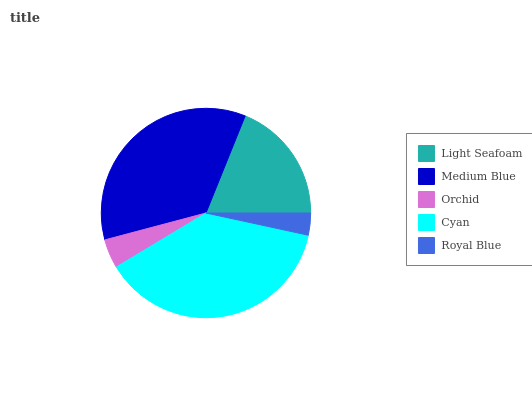Is Royal Blue the minimum?
Answer yes or no. Yes. Is Cyan the maximum?
Answer yes or no. Yes. Is Medium Blue the minimum?
Answer yes or no. No. Is Medium Blue the maximum?
Answer yes or no. No. Is Medium Blue greater than Light Seafoam?
Answer yes or no. Yes. Is Light Seafoam less than Medium Blue?
Answer yes or no. Yes. Is Light Seafoam greater than Medium Blue?
Answer yes or no. No. Is Medium Blue less than Light Seafoam?
Answer yes or no. No. Is Light Seafoam the high median?
Answer yes or no. Yes. Is Light Seafoam the low median?
Answer yes or no. Yes. Is Orchid the high median?
Answer yes or no. No. Is Royal Blue the low median?
Answer yes or no. No. 